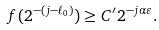Convert formula to latex. <formula><loc_0><loc_0><loc_500><loc_500>f ( 2 ^ { - ( j - \ell _ { 0 } ) } ) \geq C ^ { \prime } 2 ^ { - j \alpha \varepsilon } .</formula> 